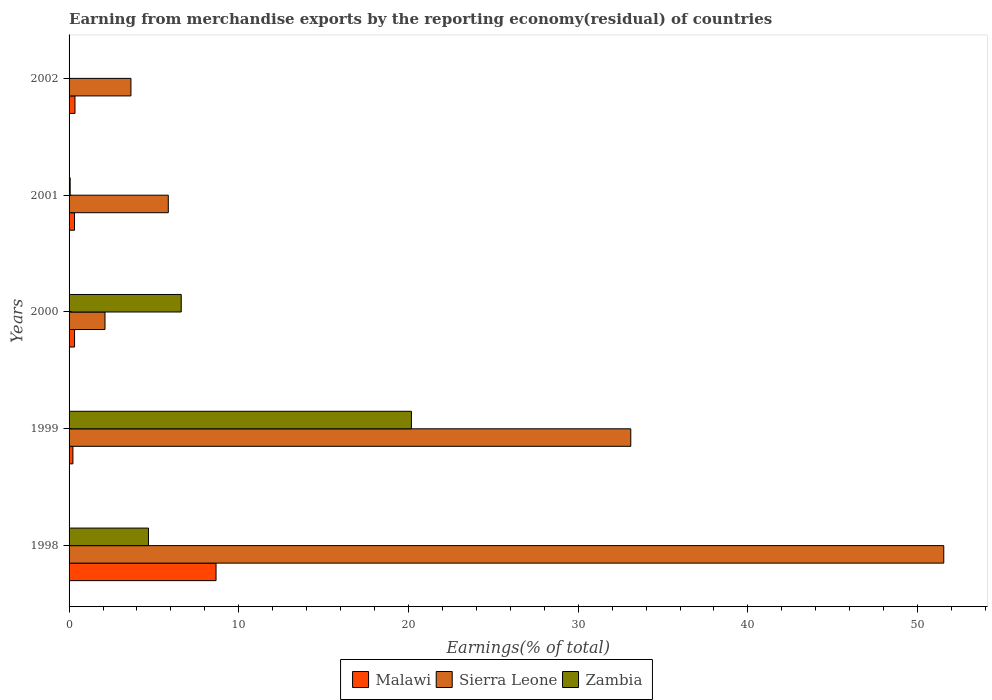Are the number of bars per tick equal to the number of legend labels?
Keep it short and to the point. Yes. How many bars are there on the 3rd tick from the bottom?
Your response must be concise. 3. In how many cases, is the number of bars for a given year not equal to the number of legend labels?
Offer a terse response. 0. What is the percentage of amount earned from merchandise exports in Sierra Leone in 2001?
Your answer should be very brief. 5.85. Across all years, what is the maximum percentage of amount earned from merchandise exports in Sierra Leone?
Provide a short and direct response. 51.54. Across all years, what is the minimum percentage of amount earned from merchandise exports in Malawi?
Keep it short and to the point. 0.23. In which year was the percentage of amount earned from merchandise exports in Malawi minimum?
Provide a succinct answer. 1999. What is the total percentage of amount earned from merchandise exports in Zambia in the graph?
Offer a terse response. 31.53. What is the difference between the percentage of amount earned from merchandise exports in Malawi in 1998 and that in 2000?
Provide a short and direct response. 8.34. What is the difference between the percentage of amount earned from merchandise exports in Malawi in 2000 and the percentage of amount earned from merchandise exports in Sierra Leone in 1998?
Provide a short and direct response. -51.22. What is the average percentage of amount earned from merchandise exports in Sierra Leone per year?
Give a very brief answer. 19.25. In the year 1998, what is the difference between the percentage of amount earned from merchandise exports in Malawi and percentage of amount earned from merchandise exports in Sierra Leone?
Keep it short and to the point. -42.88. In how many years, is the percentage of amount earned from merchandise exports in Malawi greater than 24 %?
Ensure brevity in your answer.  0. What is the ratio of the percentage of amount earned from merchandise exports in Zambia in 1999 to that in 2002?
Offer a terse response. 1.22e+04. Is the percentage of amount earned from merchandise exports in Zambia in 1998 less than that in 2002?
Your response must be concise. No. What is the difference between the highest and the second highest percentage of amount earned from merchandise exports in Sierra Leone?
Keep it short and to the point. 18.44. What is the difference between the highest and the lowest percentage of amount earned from merchandise exports in Zambia?
Provide a succinct answer. 20.17. In how many years, is the percentage of amount earned from merchandise exports in Sierra Leone greater than the average percentage of amount earned from merchandise exports in Sierra Leone taken over all years?
Your answer should be very brief. 2. What does the 2nd bar from the top in 1998 represents?
Your answer should be very brief. Sierra Leone. What does the 1st bar from the bottom in 1998 represents?
Make the answer very short. Malawi. Does the graph contain any zero values?
Keep it short and to the point. No. Does the graph contain grids?
Provide a succinct answer. No. How many legend labels are there?
Give a very brief answer. 3. What is the title of the graph?
Give a very brief answer. Earning from merchandise exports by the reporting economy(residual) of countries. What is the label or title of the X-axis?
Make the answer very short. Earnings(% of total). What is the label or title of the Y-axis?
Provide a succinct answer. Years. What is the Earnings(% of total) of Malawi in 1998?
Provide a short and direct response. 8.66. What is the Earnings(% of total) in Sierra Leone in 1998?
Your response must be concise. 51.54. What is the Earnings(% of total) of Zambia in 1998?
Provide a short and direct response. 4.68. What is the Earnings(% of total) of Malawi in 1999?
Offer a very short reply. 0.23. What is the Earnings(% of total) of Sierra Leone in 1999?
Your answer should be compact. 33.1. What is the Earnings(% of total) of Zambia in 1999?
Keep it short and to the point. 20.17. What is the Earnings(% of total) of Malawi in 2000?
Offer a very short reply. 0.32. What is the Earnings(% of total) in Sierra Leone in 2000?
Your response must be concise. 2.12. What is the Earnings(% of total) of Zambia in 2000?
Your answer should be compact. 6.61. What is the Earnings(% of total) in Malawi in 2001?
Provide a succinct answer. 0.32. What is the Earnings(% of total) of Sierra Leone in 2001?
Keep it short and to the point. 5.85. What is the Earnings(% of total) of Zambia in 2001?
Keep it short and to the point. 0.06. What is the Earnings(% of total) in Malawi in 2002?
Provide a short and direct response. 0.35. What is the Earnings(% of total) of Sierra Leone in 2002?
Provide a succinct answer. 3.65. What is the Earnings(% of total) of Zambia in 2002?
Keep it short and to the point. 0. Across all years, what is the maximum Earnings(% of total) of Malawi?
Keep it short and to the point. 8.66. Across all years, what is the maximum Earnings(% of total) in Sierra Leone?
Your answer should be very brief. 51.54. Across all years, what is the maximum Earnings(% of total) in Zambia?
Provide a succinct answer. 20.17. Across all years, what is the minimum Earnings(% of total) of Malawi?
Provide a short and direct response. 0.23. Across all years, what is the minimum Earnings(% of total) of Sierra Leone?
Your response must be concise. 2.12. Across all years, what is the minimum Earnings(% of total) of Zambia?
Your answer should be compact. 0. What is the total Earnings(% of total) of Malawi in the graph?
Your answer should be compact. 9.88. What is the total Earnings(% of total) in Sierra Leone in the graph?
Make the answer very short. 96.25. What is the total Earnings(% of total) of Zambia in the graph?
Provide a short and direct response. 31.53. What is the difference between the Earnings(% of total) in Malawi in 1998 and that in 1999?
Offer a very short reply. 8.43. What is the difference between the Earnings(% of total) in Sierra Leone in 1998 and that in 1999?
Give a very brief answer. 18.44. What is the difference between the Earnings(% of total) of Zambia in 1998 and that in 1999?
Your answer should be very brief. -15.5. What is the difference between the Earnings(% of total) of Malawi in 1998 and that in 2000?
Give a very brief answer. 8.34. What is the difference between the Earnings(% of total) in Sierra Leone in 1998 and that in 2000?
Your answer should be very brief. 49.42. What is the difference between the Earnings(% of total) of Zambia in 1998 and that in 2000?
Your answer should be compact. -1.93. What is the difference between the Earnings(% of total) of Malawi in 1998 and that in 2001?
Offer a terse response. 8.34. What is the difference between the Earnings(% of total) in Sierra Leone in 1998 and that in 2001?
Provide a short and direct response. 45.69. What is the difference between the Earnings(% of total) in Zambia in 1998 and that in 2001?
Make the answer very short. 4.61. What is the difference between the Earnings(% of total) of Malawi in 1998 and that in 2002?
Your answer should be compact. 8.31. What is the difference between the Earnings(% of total) in Sierra Leone in 1998 and that in 2002?
Your answer should be very brief. 47.9. What is the difference between the Earnings(% of total) of Zambia in 1998 and that in 2002?
Provide a short and direct response. 4.68. What is the difference between the Earnings(% of total) of Malawi in 1999 and that in 2000?
Make the answer very short. -0.1. What is the difference between the Earnings(% of total) of Sierra Leone in 1999 and that in 2000?
Your answer should be compact. 30.98. What is the difference between the Earnings(% of total) in Zambia in 1999 and that in 2000?
Keep it short and to the point. 13.56. What is the difference between the Earnings(% of total) of Malawi in 1999 and that in 2001?
Ensure brevity in your answer.  -0.09. What is the difference between the Earnings(% of total) in Sierra Leone in 1999 and that in 2001?
Your answer should be very brief. 27.25. What is the difference between the Earnings(% of total) of Zambia in 1999 and that in 2001?
Provide a succinct answer. 20.11. What is the difference between the Earnings(% of total) of Malawi in 1999 and that in 2002?
Provide a short and direct response. -0.12. What is the difference between the Earnings(% of total) of Sierra Leone in 1999 and that in 2002?
Provide a succinct answer. 29.45. What is the difference between the Earnings(% of total) in Zambia in 1999 and that in 2002?
Your answer should be very brief. 20.17. What is the difference between the Earnings(% of total) of Malawi in 2000 and that in 2001?
Make the answer very short. 0. What is the difference between the Earnings(% of total) in Sierra Leone in 2000 and that in 2001?
Offer a very short reply. -3.73. What is the difference between the Earnings(% of total) of Zambia in 2000 and that in 2001?
Provide a succinct answer. 6.55. What is the difference between the Earnings(% of total) of Malawi in 2000 and that in 2002?
Offer a terse response. -0.03. What is the difference between the Earnings(% of total) of Sierra Leone in 2000 and that in 2002?
Your answer should be very brief. -1.53. What is the difference between the Earnings(% of total) of Zambia in 2000 and that in 2002?
Keep it short and to the point. 6.61. What is the difference between the Earnings(% of total) of Malawi in 2001 and that in 2002?
Your answer should be very brief. -0.03. What is the difference between the Earnings(% of total) of Sierra Leone in 2001 and that in 2002?
Offer a very short reply. 2.2. What is the difference between the Earnings(% of total) of Zambia in 2001 and that in 2002?
Offer a very short reply. 0.06. What is the difference between the Earnings(% of total) in Malawi in 1998 and the Earnings(% of total) in Sierra Leone in 1999?
Provide a short and direct response. -24.44. What is the difference between the Earnings(% of total) of Malawi in 1998 and the Earnings(% of total) of Zambia in 1999?
Your response must be concise. -11.51. What is the difference between the Earnings(% of total) in Sierra Leone in 1998 and the Earnings(% of total) in Zambia in 1999?
Give a very brief answer. 31.37. What is the difference between the Earnings(% of total) in Malawi in 1998 and the Earnings(% of total) in Sierra Leone in 2000?
Provide a succinct answer. 6.54. What is the difference between the Earnings(% of total) of Malawi in 1998 and the Earnings(% of total) of Zambia in 2000?
Ensure brevity in your answer.  2.05. What is the difference between the Earnings(% of total) of Sierra Leone in 1998 and the Earnings(% of total) of Zambia in 2000?
Make the answer very short. 44.93. What is the difference between the Earnings(% of total) of Malawi in 1998 and the Earnings(% of total) of Sierra Leone in 2001?
Keep it short and to the point. 2.81. What is the difference between the Earnings(% of total) of Malawi in 1998 and the Earnings(% of total) of Zambia in 2001?
Offer a terse response. 8.6. What is the difference between the Earnings(% of total) in Sierra Leone in 1998 and the Earnings(% of total) in Zambia in 2001?
Give a very brief answer. 51.48. What is the difference between the Earnings(% of total) in Malawi in 1998 and the Earnings(% of total) in Sierra Leone in 2002?
Offer a terse response. 5.01. What is the difference between the Earnings(% of total) in Malawi in 1998 and the Earnings(% of total) in Zambia in 2002?
Your answer should be compact. 8.66. What is the difference between the Earnings(% of total) of Sierra Leone in 1998 and the Earnings(% of total) of Zambia in 2002?
Offer a terse response. 51.54. What is the difference between the Earnings(% of total) in Malawi in 1999 and the Earnings(% of total) in Sierra Leone in 2000?
Make the answer very short. -1.89. What is the difference between the Earnings(% of total) of Malawi in 1999 and the Earnings(% of total) of Zambia in 2000?
Your answer should be very brief. -6.38. What is the difference between the Earnings(% of total) in Sierra Leone in 1999 and the Earnings(% of total) in Zambia in 2000?
Ensure brevity in your answer.  26.49. What is the difference between the Earnings(% of total) of Malawi in 1999 and the Earnings(% of total) of Sierra Leone in 2001?
Offer a terse response. -5.62. What is the difference between the Earnings(% of total) in Malawi in 1999 and the Earnings(% of total) in Zambia in 2001?
Give a very brief answer. 0.16. What is the difference between the Earnings(% of total) in Sierra Leone in 1999 and the Earnings(% of total) in Zambia in 2001?
Offer a very short reply. 33.03. What is the difference between the Earnings(% of total) of Malawi in 1999 and the Earnings(% of total) of Sierra Leone in 2002?
Offer a terse response. -3.42. What is the difference between the Earnings(% of total) in Malawi in 1999 and the Earnings(% of total) in Zambia in 2002?
Provide a succinct answer. 0.22. What is the difference between the Earnings(% of total) of Sierra Leone in 1999 and the Earnings(% of total) of Zambia in 2002?
Provide a succinct answer. 33.1. What is the difference between the Earnings(% of total) in Malawi in 2000 and the Earnings(% of total) in Sierra Leone in 2001?
Your answer should be very brief. -5.52. What is the difference between the Earnings(% of total) of Malawi in 2000 and the Earnings(% of total) of Zambia in 2001?
Keep it short and to the point. 0.26. What is the difference between the Earnings(% of total) in Sierra Leone in 2000 and the Earnings(% of total) in Zambia in 2001?
Your answer should be compact. 2.05. What is the difference between the Earnings(% of total) of Malawi in 2000 and the Earnings(% of total) of Sierra Leone in 2002?
Your answer should be compact. -3.32. What is the difference between the Earnings(% of total) of Malawi in 2000 and the Earnings(% of total) of Zambia in 2002?
Make the answer very short. 0.32. What is the difference between the Earnings(% of total) of Sierra Leone in 2000 and the Earnings(% of total) of Zambia in 2002?
Your answer should be very brief. 2.12. What is the difference between the Earnings(% of total) in Malawi in 2001 and the Earnings(% of total) in Sierra Leone in 2002?
Offer a very short reply. -3.33. What is the difference between the Earnings(% of total) in Malawi in 2001 and the Earnings(% of total) in Zambia in 2002?
Provide a short and direct response. 0.32. What is the difference between the Earnings(% of total) in Sierra Leone in 2001 and the Earnings(% of total) in Zambia in 2002?
Offer a terse response. 5.84. What is the average Earnings(% of total) in Malawi per year?
Make the answer very short. 1.98. What is the average Earnings(% of total) in Sierra Leone per year?
Offer a very short reply. 19.25. What is the average Earnings(% of total) of Zambia per year?
Your answer should be very brief. 6.31. In the year 1998, what is the difference between the Earnings(% of total) of Malawi and Earnings(% of total) of Sierra Leone?
Keep it short and to the point. -42.88. In the year 1998, what is the difference between the Earnings(% of total) in Malawi and Earnings(% of total) in Zambia?
Ensure brevity in your answer.  3.98. In the year 1998, what is the difference between the Earnings(% of total) of Sierra Leone and Earnings(% of total) of Zambia?
Make the answer very short. 46.86. In the year 1999, what is the difference between the Earnings(% of total) of Malawi and Earnings(% of total) of Sierra Leone?
Your answer should be very brief. -32.87. In the year 1999, what is the difference between the Earnings(% of total) of Malawi and Earnings(% of total) of Zambia?
Provide a short and direct response. -19.95. In the year 1999, what is the difference between the Earnings(% of total) in Sierra Leone and Earnings(% of total) in Zambia?
Your answer should be compact. 12.93. In the year 2000, what is the difference between the Earnings(% of total) of Malawi and Earnings(% of total) of Sierra Leone?
Make the answer very short. -1.79. In the year 2000, what is the difference between the Earnings(% of total) of Malawi and Earnings(% of total) of Zambia?
Provide a succinct answer. -6.29. In the year 2000, what is the difference between the Earnings(% of total) in Sierra Leone and Earnings(% of total) in Zambia?
Make the answer very short. -4.49. In the year 2001, what is the difference between the Earnings(% of total) in Malawi and Earnings(% of total) in Sierra Leone?
Provide a succinct answer. -5.53. In the year 2001, what is the difference between the Earnings(% of total) in Malawi and Earnings(% of total) in Zambia?
Your answer should be compact. 0.26. In the year 2001, what is the difference between the Earnings(% of total) in Sierra Leone and Earnings(% of total) in Zambia?
Offer a terse response. 5.78. In the year 2002, what is the difference between the Earnings(% of total) in Malawi and Earnings(% of total) in Sierra Leone?
Provide a succinct answer. -3.3. In the year 2002, what is the difference between the Earnings(% of total) in Malawi and Earnings(% of total) in Zambia?
Give a very brief answer. 0.35. In the year 2002, what is the difference between the Earnings(% of total) in Sierra Leone and Earnings(% of total) in Zambia?
Offer a terse response. 3.64. What is the ratio of the Earnings(% of total) in Malawi in 1998 to that in 1999?
Make the answer very short. 38.31. What is the ratio of the Earnings(% of total) in Sierra Leone in 1998 to that in 1999?
Your response must be concise. 1.56. What is the ratio of the Earnings(% of total) in Zambia in 1998 to that in 1999?
Make the answer very short. 0.23. What is the ratio of the Earnings(% of total) of Malawi in 1998 to that in 2000?
Your response must be concise. 26.76. What is the ratio of the Earnings(% of total) of Sierra Leone in 1998 to that in 2000?
Ensure brevity in your answer.  24.34. What is the ratio of the Earnings(% of total) in Zambia in 1998 to that in 2000?
Ensure brevity in your answer.  0.71. What is the ratio of the Earnings(% of total) of Malawi in 1998 to that in 2001?
Keep it short and to the point. 27.03. What is the ratio of the Earnings(% of total) of Sierra Leone in 1998 to that in 2001?
Provide a succinct answer. 8.82. What is the ratio of the Earnings(% of total) in Zambia in 1998 to that in 2001?
Offer a terse response. 72.63. What is the ratio of the Earnings(% of total) of Malawi in 1998 to that in 2002?
Your answer should be compact. 24.83. What is the ratio of the Earnings(% of total) of Sierra Leone in 1998 to that in 2002?
Your answer should be very brief. 14.14. What is the ratio of the Earnings(% of total) of Zambia in 1998 to that in 2002?
Your answer should be very brief. 2818.63. What is the ratio of the Earnings(% of total) in Malawi in 1999 to that in 2000?
Make the answer very short. 0.7. What is the ratio of the Earnings(% of total) in Sierra Leone in 1999 to that in 2000?
Make the answer very short. 15.63. What is the ratio of the Earnings(% of total) in Zambia in 1999 to that in 2000?
Offer a terse response. 3.05. What is the ratio of the Earnings(% of total) of Malawi in 1999 to that in 2001?
Keep it short and to the point. 0.71. What is the ratio of the Earnings(% of total) in Sierra Leone in 1999 to that in 2001?
Your response must be concise. 5.66. What is the ratio of the Earnings(% of total) of Zambia in 1999 to that in 2001?
Offer a terse response. 313.18. What is the ratio of the Earnings(% of total) of Malawi in 1999 to that in 2002?
Your response must be concise. 0.65. What is the ratio of the Earnings(% of total) in Sierra Leone in 1999 to that in 2002?
Keep it short and to the point. 9.08. What is the ratio of the Earnings(% of total) of Zambia in 1999 to that in 2002?
Make the answer very short. 1.22e+04. What is the ratio of the Earnings(% of total) in Malawi in 2000 to that in 2001?
Your answer should be compact. 1.01. What is the ratio of the Earnings(% of total) in Sierra Leone in 2000 to that in 2001?
Provide a succinct answer. 0.36. What is the ratio of the Earnings(% of total) in Zambia in 2000 to that in 2001?
Provide a short and direct response. 102.61. What is the ratio of the Earnings(% of total) in Malawi in 2000 to that in 2002?
Give a very brief answer. 0.93. What is the ratio of the Earnings(% of total) of Sierra Leone in 2000 to that in 2002?
Provide a short and direct response. 0.58. What is the ratio of the Earnings(% of total) in Zambia in 2000 to that in 2002?
Ensure brevity in your answer.  3982.34. What is the ratio of the Earnings(% of total) in Malawi in 2001 to that in 2002?
Your answer should be compact. 0.92. What is the ratio of the Earnings(% of total) of Sierra Leone in 2001 to that in 2002?
Make the answer very short. 1.6. What is the ratio of the Earnings(% of total) of Zambia in 2001 to that in 2002?
Keep it short and to the point. 38.81. What is the difference between the highest and the second highest Earnings(% of total) of Malawi?
Your answer should be very brief. 8.31. What is the difference between the highest and the second highest Earnings(% of total) of Sierra Leone?
Your response must be concise. 18.44. What is the difference between the highest and the second highest Earnings(% of total) of Zambia?
Your answer should be very brief. 13.56. What is the difference between the highest and the lowest Earnings(% of total) in Malawi?
Give a very brief answer. 8.43. What is the difference between the highest and the lowest Earnings(% of total) in Sierra Leone?
Make the answer very short. 49.42. What is the difference between the highest and the lowest Earnings(% of total) in Zambia?
Your response must be concise. 20.17. 